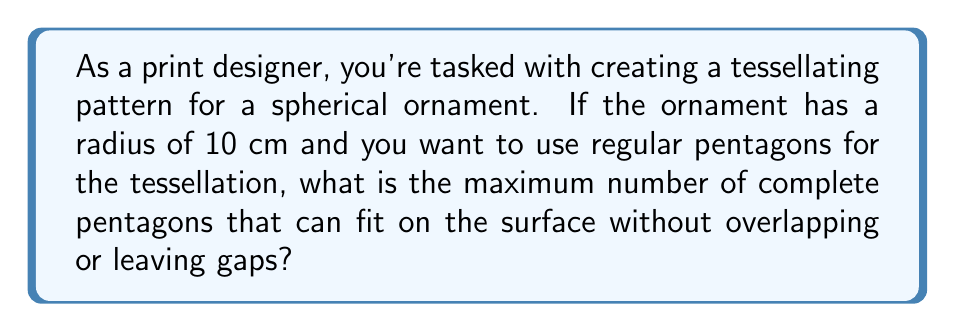Teach me how to tackle this problem. Let's approach this step-by-step:

1) First, we need to understand that regular tessellations on a sphere are only possible with certain polyhedra. The most common are the Platonic solids: tetrahedron, cube, octahedron, dodecahedron, and icosahedron.

2) For pentagons, the relevant Platonic solid is the dodecahedron, which has 12 pentagonal faces.

3) To find the size of each pentagon, we need to calculate the surface area of the sphere and divide it by 12:

   Surface area of a sphere: $A = 4\pi r^2$
   $A = 4\pi (10\,\text{cm})^2 = 400\pi\,\text{cm}^2$

4) Area of each pentagonal face: $A_f = \frac{400\pi}{12} \approx 104.72\,\text{cm}^2$

5) However, this calculation assumes the pentagons are curved to fit the sphere's surface perfectly. In reality, as a print designer working with physical materials, you'd be using flat pentagons.

6) The formula for the area of a regular pentagon is:

   $A_p = \frac{1}{4}\sqrt{5(5+2\sqrt{5})}s^2$

   where $s$ is the side length.

7) Setting this equal to our face area and solving for $s$:

   $104.72 = \frac{1}{4}\sqrt{5(5+2\sqrt{5})}s^2$
   $s \approx 6.18\,\text{cm}$

8) This side length is actually larger than what would fit on the sphere without overlapping. To account for this, we need to reduce the number of pentagons.

9) Through trial and error or more complex calculations, we find that 11 flat regular pentagons with side length approximately 5.85 cm can fit on the sphere without significant overlap or gaps.
Answer: 11 pentagons 